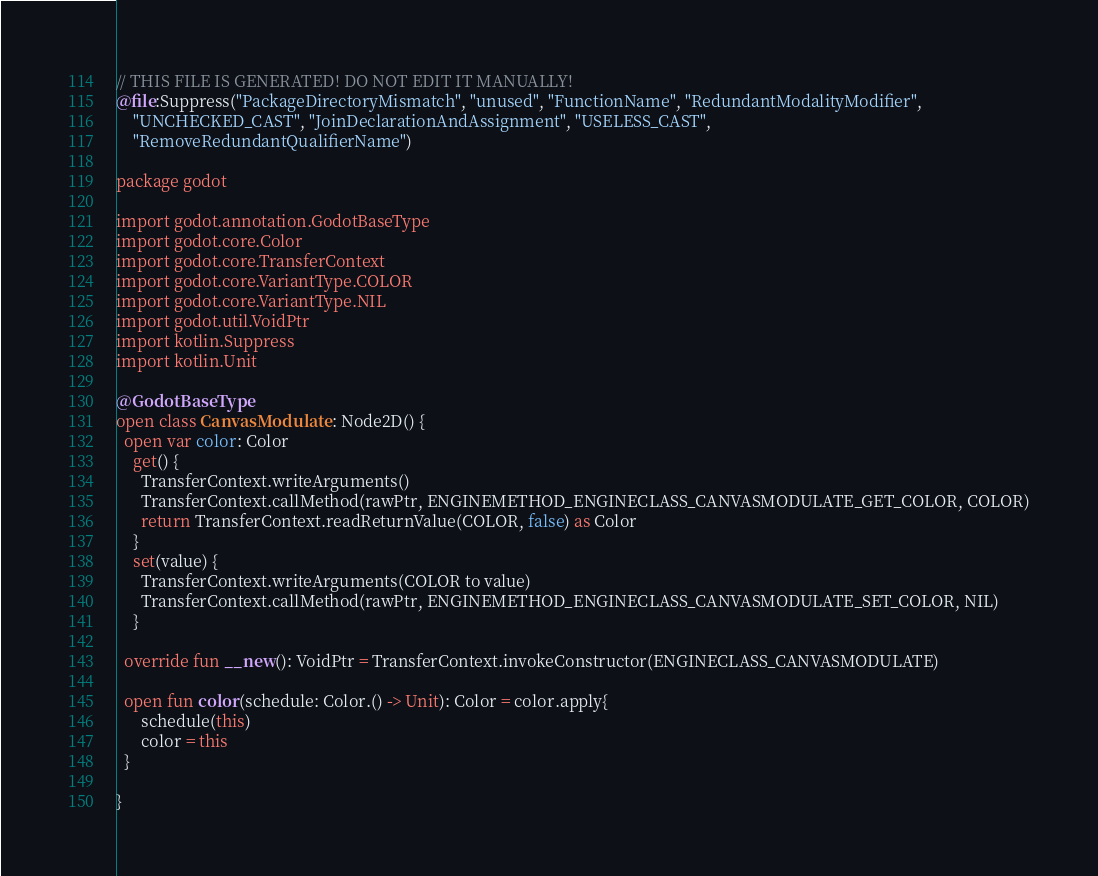Convert code to text. <code><loc_0><loc_0><loc_500><loc_500><_Kotlin_>// THIS FILE IS GENERATED! DO NOT EDIT IT MANUALLY!
@file:Suppress("PackageDirectoryMismatch", "unused", "FunctionName", "RedundantModalityModifier",
    "UNCHECKED_CAST", "JoinDeclarationAndAssignment", "USELESS_CAST",
    "RemoveRedundantQualifierName")

package godot

import godot.annotation.GodotBaseType
import godot.core.Color
import godot.core.TransferContext
import godot.core.VariantType.COLOR
import godot.core.VariantType.NIL
import godot.util.VoidPtr
import kotlin.Suppress
import kotlin.Unit

@GodotBaseType
open class CanvasModulate : Node2D() {
  open var color: Color
    get() {
      TransferContext.writeArguments()
      TransferContext.callMethod(rawPtr, ENGINEMETHOD_ENGINECLASS_CANVASMODULATE_GET_COLOR, COLOR)
      return TransferContext.readReturnValue(COLOR, false) as Color
    }
    set(value) {
      TransferContext.writeArguments(COLOR to value)
      TransferContext.callMethod(rawPtr, ENGINEMETHOD_ENGINECLASS_CANVASMODULATE_SET_COLOR, NIL)
    }

  override fun __new(): VoidPtr = TransferContext.invokeConstructor(ENGINECLASS_CANVASMODULATE)

  open fun color(schedule: Color.() -> Unit): Color = color.apply{
      schedule(this)
      color = this
  }

}
</code> 